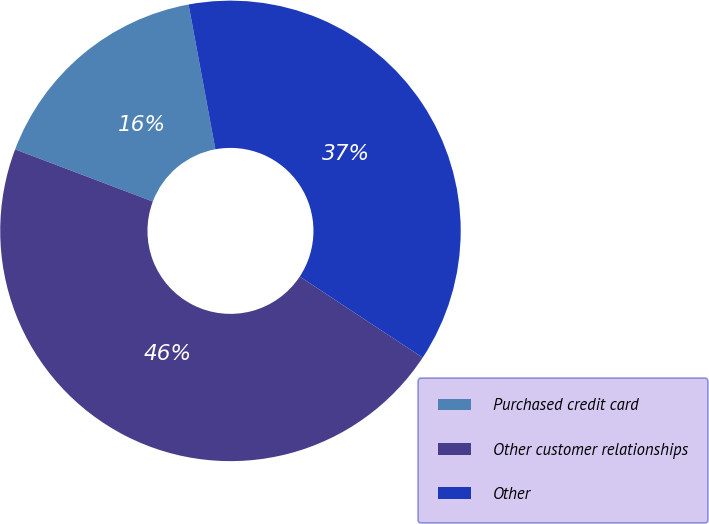Convert chart to OTSL. <chart><loc_0><loc_0><loc_500><loc_500><pie_chart><fcel>Purchased credit card<fcel>Other customer relationships<fcel>Other<nl><fcel>16.33%<fcel>46.48%<fcel>37.19%<nl></chart> 